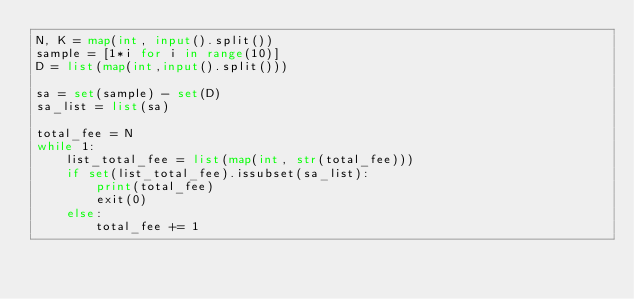<code> <loc_0><loc_0><loc_500><loc_500><_Python_>N, K = map(int, input().split())
sample = [1*i for i in range(10)]
D = list(map(int,input().split()))

sa = set(sample) - set(D)
sa_list = list(sa)

total_fee = N
while 1:
    list_total_fee = list(map(int, str(total_fee)))
    if set(list_total_fee).issubset(sa_list):
        print(total_fee)
        exit(0)
    else:
        total_fee += 1</code> 